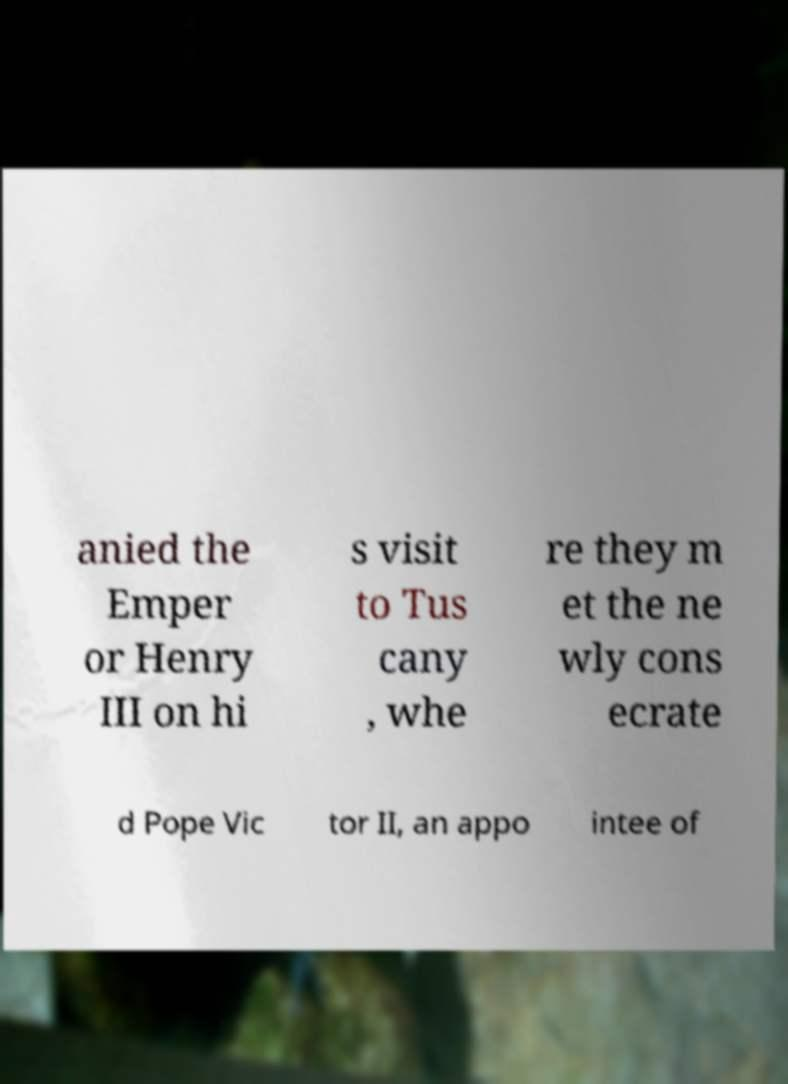Please identify and transcribe the text found in this image. anied the Emper or Henry III on hi s visit to Tus cany , whe re they m et the ne wly cons ecrate d Pope Vic tor II, an appo intee of 